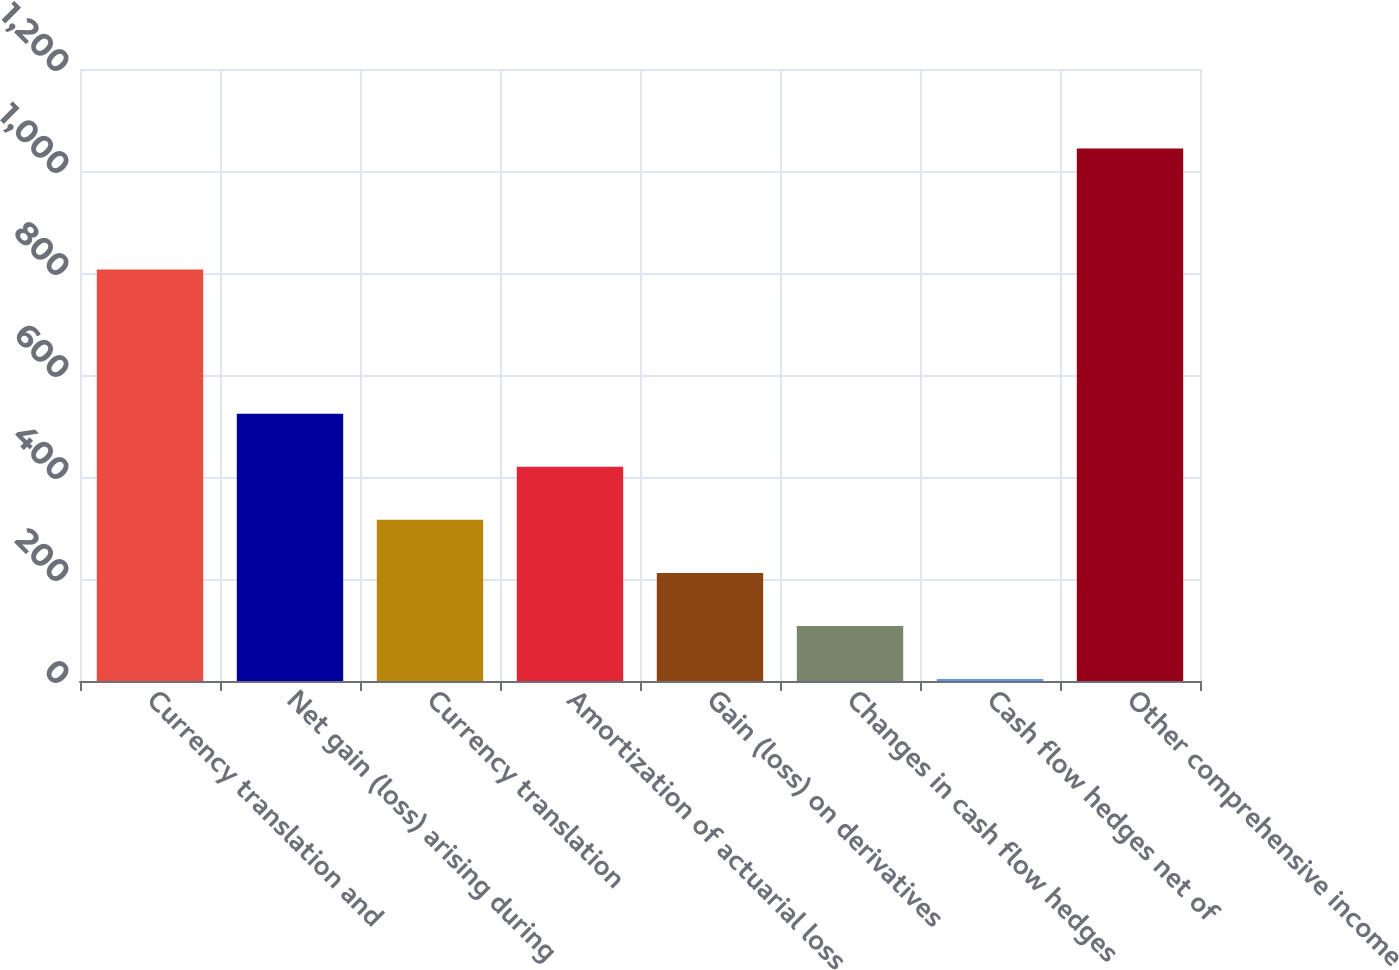<chart> <loc_0><loc_0><loc_500><loc_500><bar_chart><fcel>Currency translation and<fcel>Net gain (loss) arising during<fcel>Currency translation<fcel>Amortization of actuarial loss<fcel>Gain (loss) on derivatives<fcel>Changes in cash flow hedges<fcel>Cash flow hedges net of<fcel>Other comprehensive income<nl><fcel>807<fcel>524<fcel>316<fcel>420<fcel>212<fcel>108<fcel>4<fcel>1044<nl></chart> 